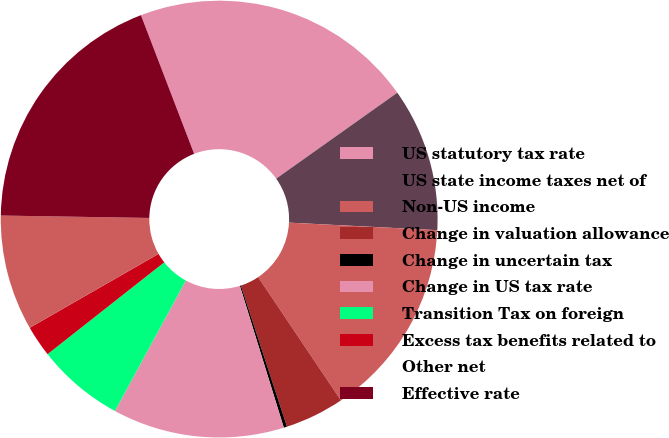Convert chart to OTSL. <chart><loc_0><loc_0><loc_500><loc_500><pie_chart><fcel>US statutory tax rate<fcel>US state income taxes net of<fcel>Non-US income<fcel>Change in valuation allowance<fcel>Change in uncertain tax<fcel>Change in US tax rate<fcel>Transition Tax on foreign<fcel>Excess tax benefits related to<fcel>Other net<fcel>Effective rate<nl><fcel>21.01%<fcel>10.63%<fcel>14.78%<fcel>4.39%<fcel>0.24%<fcel>12.7%<fcel>6.47%<fcel>2.32%<fcel>8.55%<fcel>18.91%<nl></chart> 